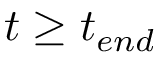<formula> <loc_0><loc_0><loc_500><loc_500>t \geq t _ { e n d }</formula> 